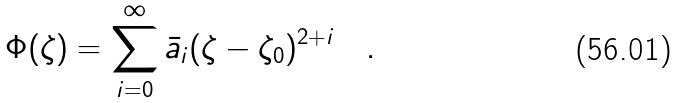<formula> <loc_0><loc_0><loc_500><loc_500>\Phi ( \zeta ) = \sum _ { i = 0 } ^ { \infty } \bar { a } _ { i } ( \zeta - \zeta _ { 0 } ) ^ { 2 + i } \quad .</formula> 